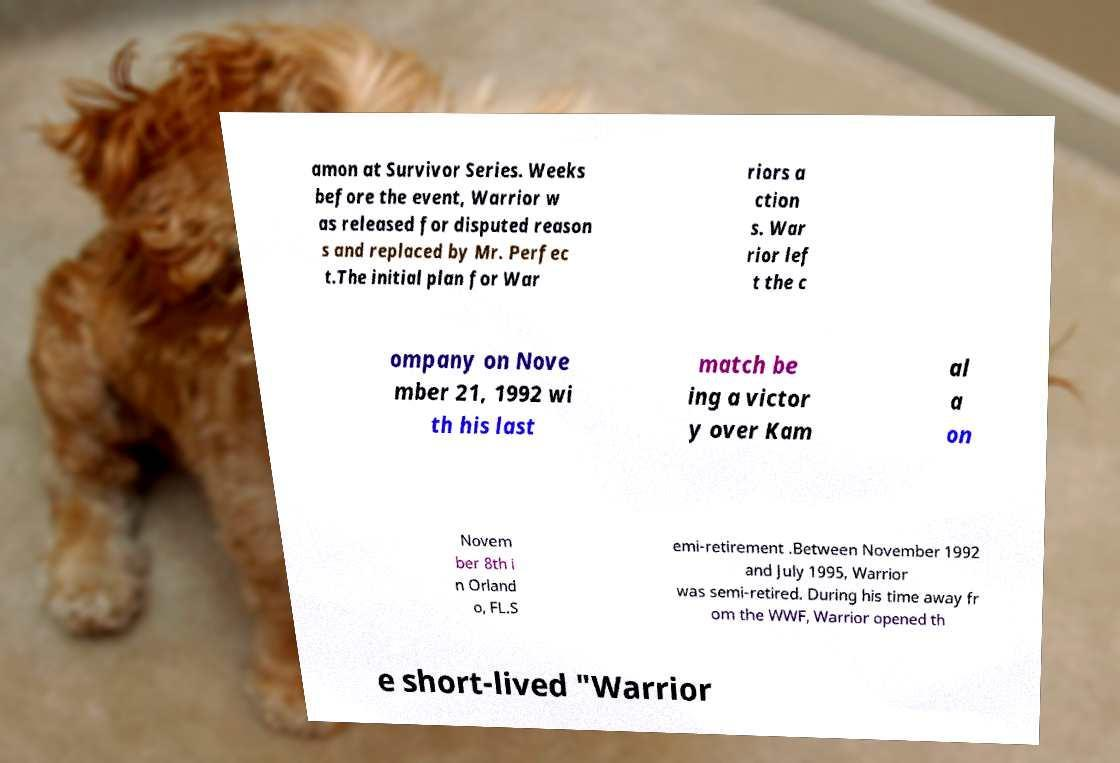I need the written content from this picture converted into text. Can you do that? amon at Survivor Series. Weeks before the event, Warrior w as released for disputed reason s and replaced by Mr. Perfec t.The initial plan for War riors a ction s. War rior lef t the c ompany on Nove mber 21, 1992 wi th his last match be ing a victor y over Kam al a on Novem ber 8th i n Orland o, FL.S emi-retirement .Between November 1992 and July 1995, Warrior was semi-retired. During his time away fr om the WWF, Warrior opened th e short-lived "Warrior 